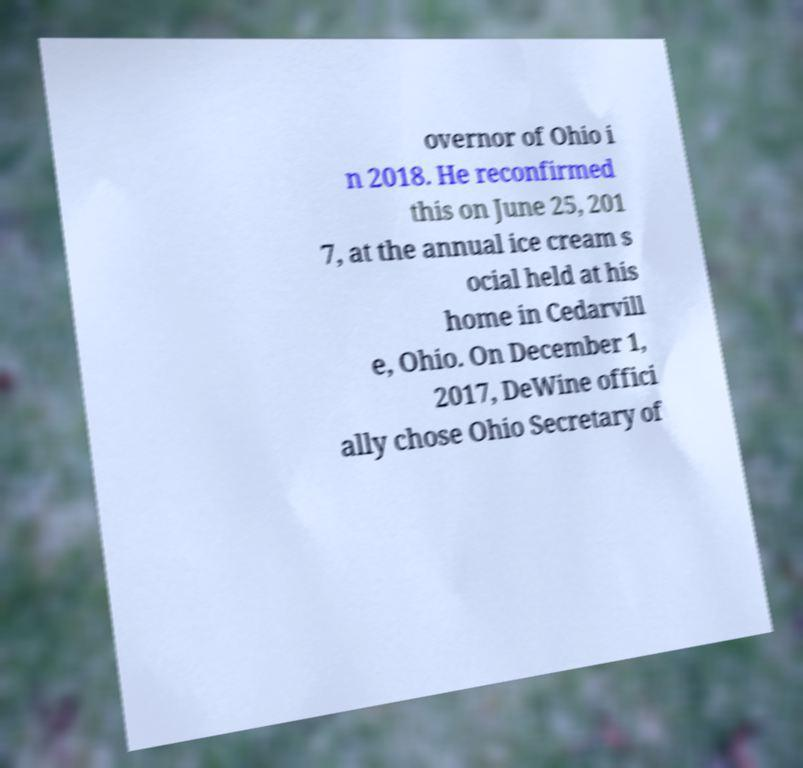Can you read and provide the text displayed in the image?This photo seems to have some interesting text. Can you extract and type it out for me? overnor of Ohio i n 2018. He reconfirmed this on June 25, 201 7, at the annual ice cream s ocial held at his home in Cedarvill e, Ohio. On December 1, 2017, DeWine offici ally chose Ohio Secretary of 